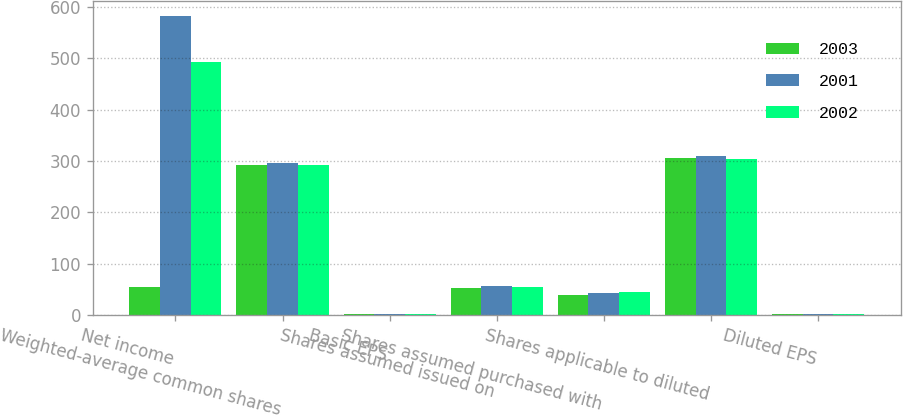Convert chart. <chart><loc_0><loc_0><loc_500><loc_500><stacked_bar_chart><ecel><fcel>Net income<fcel>Weighted-average common shares<fcel>Basic EPS<fcel>Shares assumed issued on<fcel>Shares assumed purchased with<fcel>Shares applicable to diluted<fcel>Diluted EPS<nl><fcel>2003<fcel>53.5<fcel>293<fcel>2.1<fcel>52<fcel>39<fcel>306<fcel>2.02<nl><fcel>2001<fcel>583<fcel>296<fcel>1.97<fcel>56<fcel>42<fcel>310<fcel>1.88<nl><fcel>2002<fcel>492<fcel>293<fcel>1.68<fcel>55<fcel>44<fcel>304<fcel>1.62<nl></chart> 